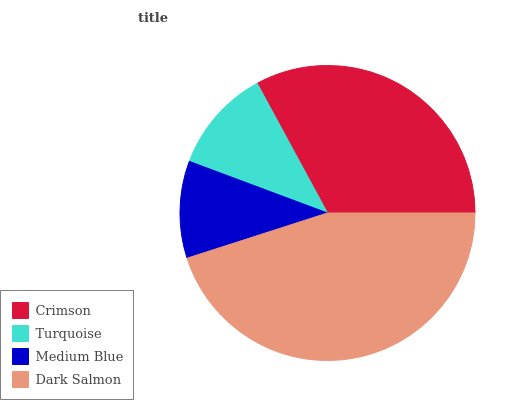Is Medium Blue the minimum?
Answer yes or no. Yes. Is Dark Salmon the maximum?
Answer yes or no. Yes. Is Turquoise the minimum?
Answer yes or no. No. Is Turquoise the maximum?
Answer yes or no. No. Is Crimson greater than Turquoise?
Answer yes or no. Yes. Is Turquoise less than Crimson?
Answer yes or no. Yes. Is Turquoise greater than Crimson?
Answer yes or no. No. Is Crimson less than Turquoise?
Answer yes or no. No. Is Crimson the high median?
Answer yes or no. Yes. Is Turquoise the low median?
Answer yes or no. Yes. Is Turquoise the high median?
Answer yes or no. No. Is Dark Salmon the low median?
Answer yes or no. No. 